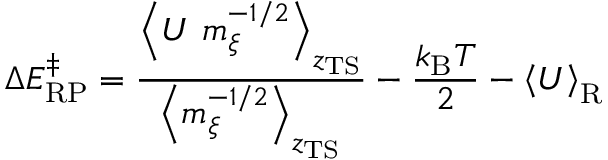<formula> <loc_0><loc_0><loc_500><loc_500>\Delta E _ { R P } ^ { \ddagger } = \frac { \left < U \ m _ { \xi } ^ { - 1 / 2 } \right > _ { z _ { T S } } } { \left < m _ { \xi } ^ { - 1 / 2 } \right > _ { z _ { T S } } } - \frac { k _ { B } T } { 2 } - \left < U \right > _ { R }</formula> 